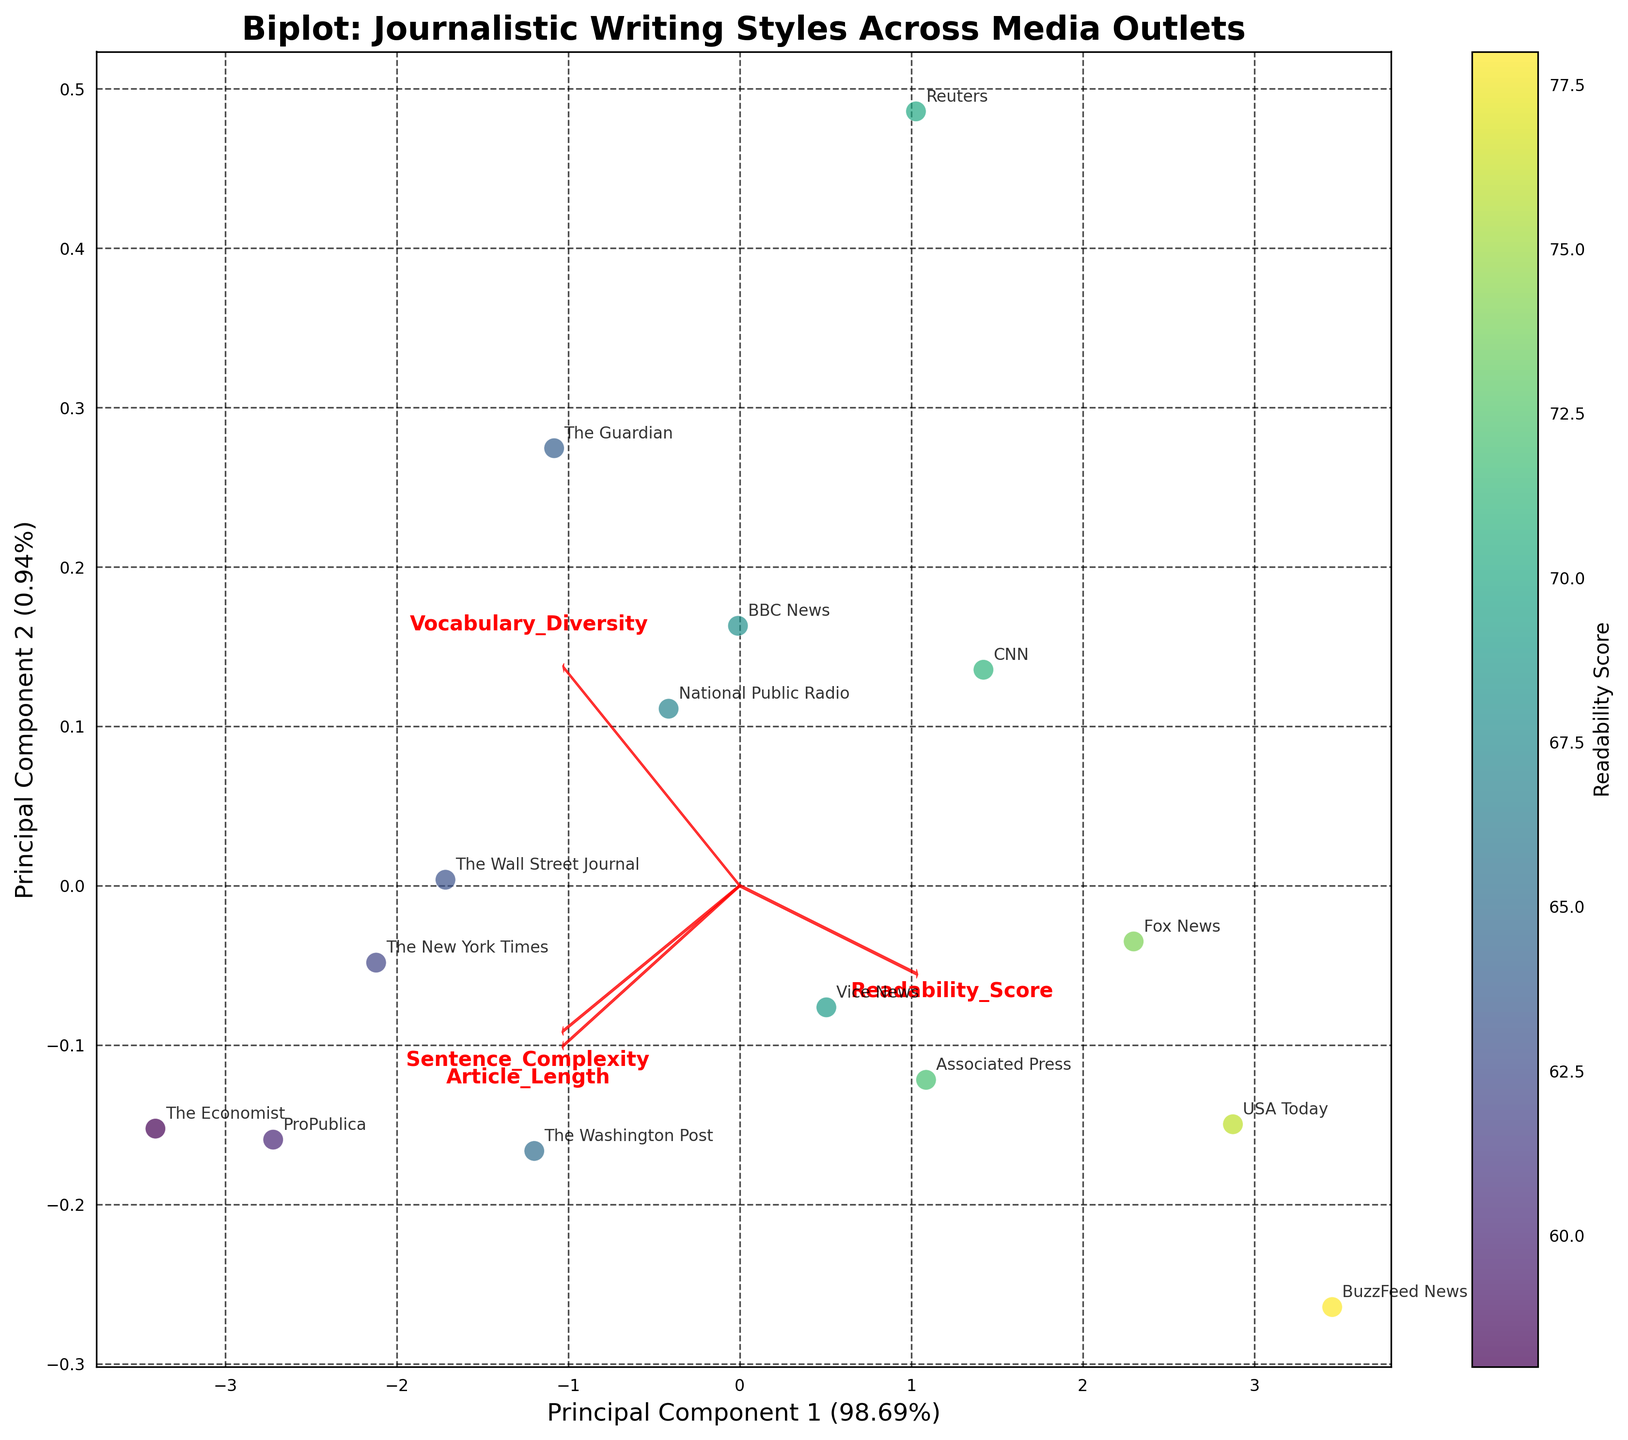What is the title of the figure? The title is generally located at the top of the figure and provides a concise description of what the figure represents. In this case, the title is "Biplot: Journalistic Writing Styles Across Media Outlets".
Answer: Biplot: Journalistic Writing Styles Across Media Outlets Which media outlet has the highest Sentence Complexity? To identify the media outlet with the highest Sentence Complexity, look for the vector labeled "Sentence_Complexity" and follow it to the data point farthest along this vector. The Economist has the highest Sentence Complexity.
Answer: The Economist How are Sentence Complexity and Readability Score related according to the loadings? The direction of the arrows (loadings) represent how different features influence the principal components. The Sentence_Complexity arrow points in a different direction from the Readability_Score arrow, indicating these features are inversely related in the space of the principal components.
Answer: Inversely related Which publication appears closest to the arrow corresponding to Vocabulary Diversity? Look at the arrow labeled "Vocabulary_Diversity" and see which data point is nearest to it. ProPublica is closest to the Vocabulary Diversity arrow.
Answer: ProPublica Which principal component explains more variance in the data? The x-axis and y-axis labels include the percentage of variance each principal component explains. The x-axis label for Principal Component 1 shows it explains more variance than the y-axis label for Principal Component 2.
Answer: Principal Component 1 What are the two principal components labeled on the axes? The axes labels typically specify the principal components. In this case, they are labeled as Principal Component 1 and Principal Component 2.
Answer: Principal Component 1 and Principal Component 2 What color represents the lowest Readability Score? The colorbar to the side of the scatter plot shows a gradient of colors corresponding to Readability Scores. The lowest Readability Score is indicated by the darkest color in this color palette.
Answer: Dark Purple Which publication has the lowest Vocabulary Diversity? To find the publication with the lowest Vocabulary Diversity, locate the end of the Vocabulary_Diversity arrow and look for the data point farthest in the opposite direction. BuzzFeed News has the lowest Vocabulary Diversity.
Answer: BuzzFeed News How many media outlets are analyzed in the biplot? Count the number of data points or look at the annotations for each media outlet in the plot. There are 15 media outlets analyzed.
Answer: 15 